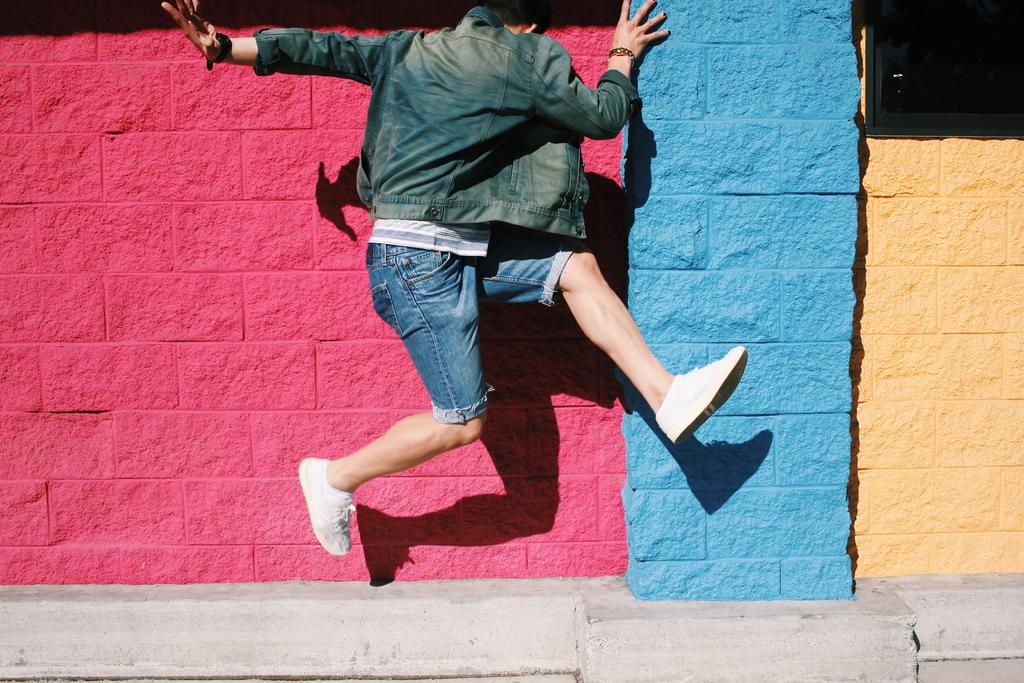Who is present in the image? There is a person in the image. What is the person wearing? The person is wearing a denim jacket and shorts. What is the person doing in the image? The person is jumping. What can be seen in the background of the image? There is a colorful wall in the background of the image. What type of art is being committed in the image? There is no art or crime being committed in the image; it simply shows a person jumping in front of a colorful wall. 